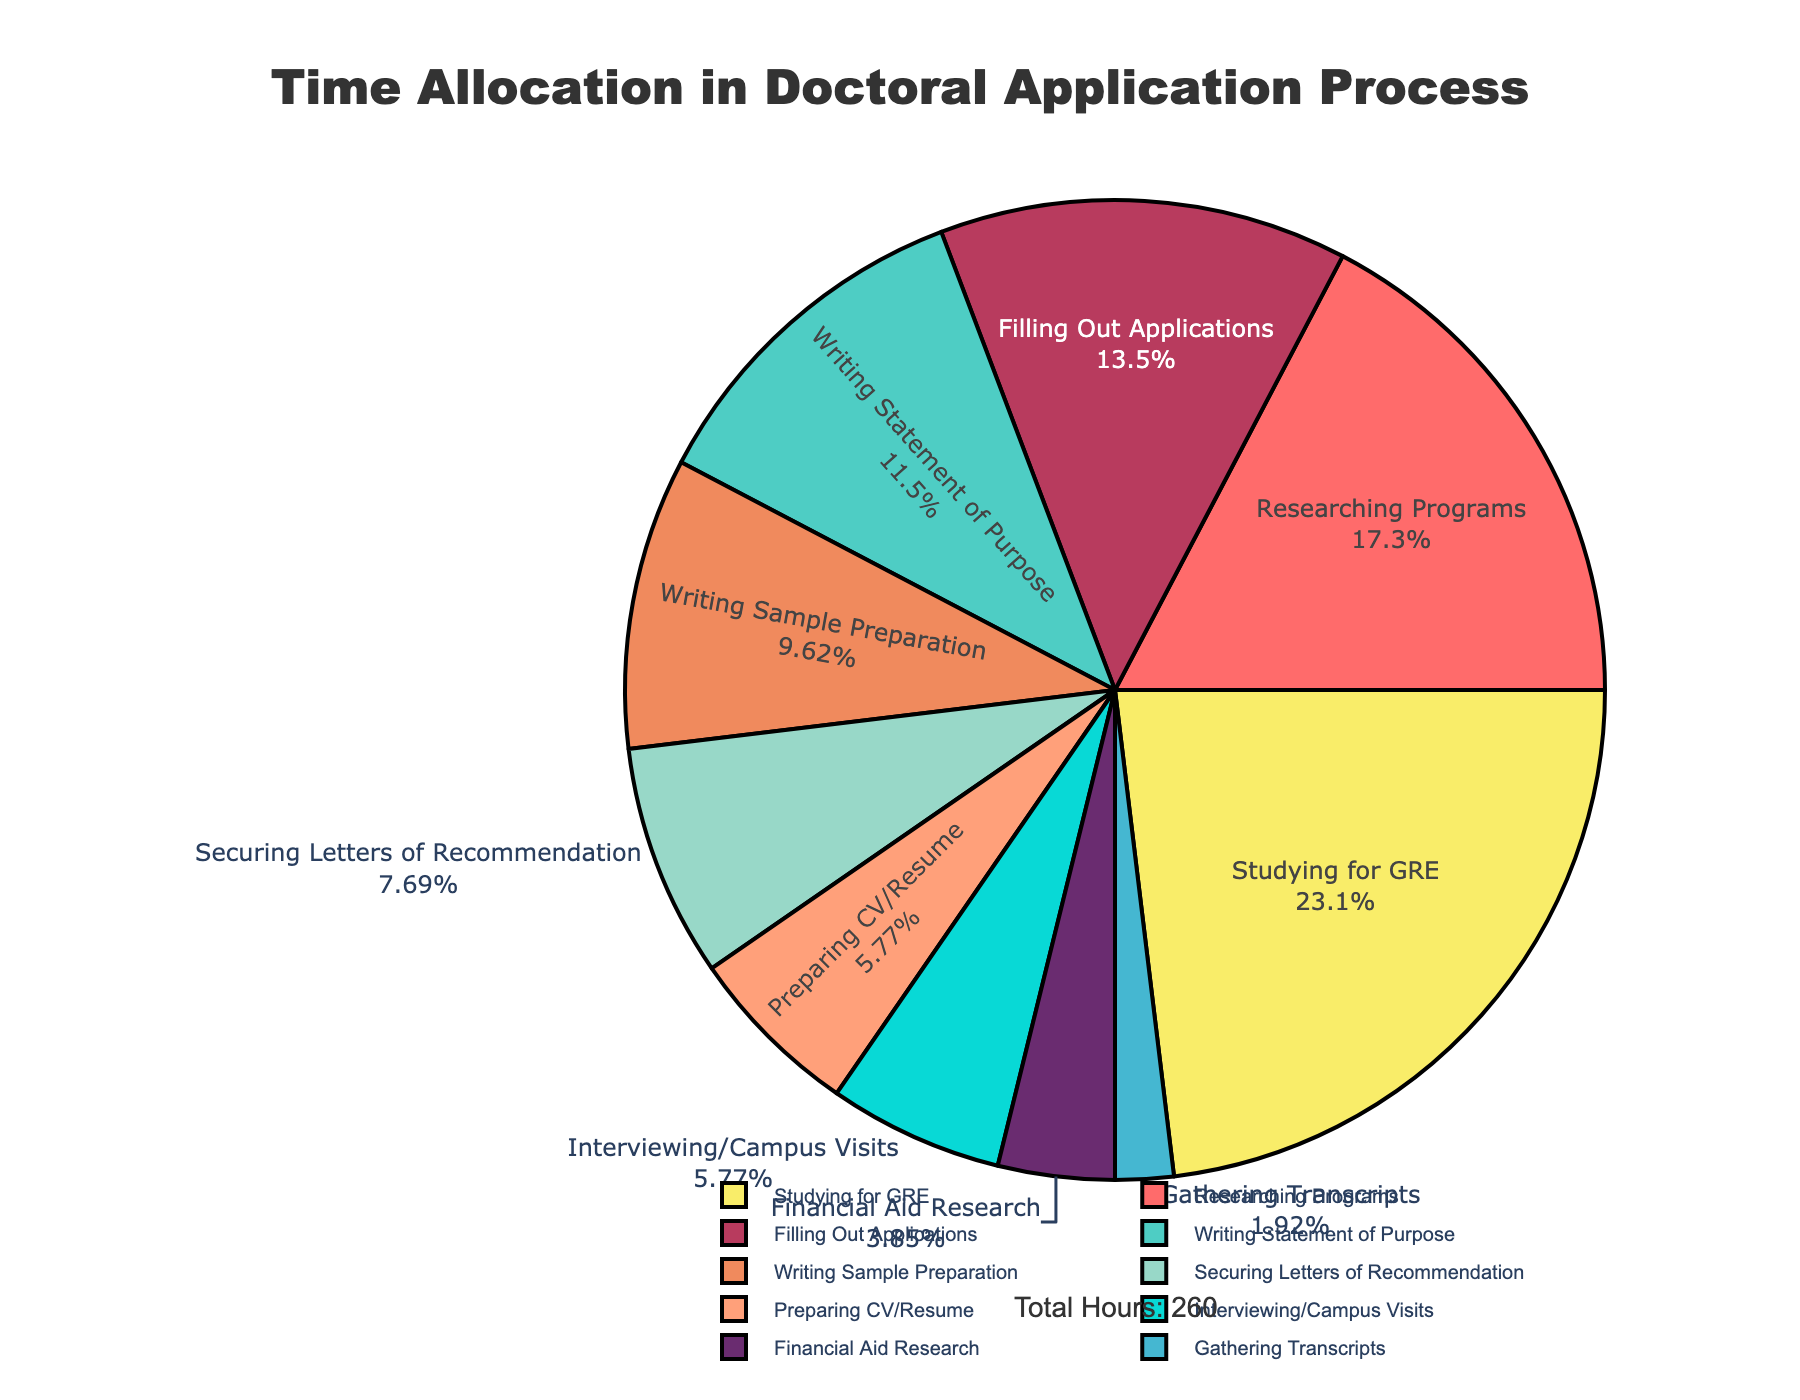Which activity consumes the most amount of time? By visually inspecting the pie chart, we can identify the largest segment, indicating the activity that takes up the most hours.
Answer: Studying for GRE How much combined time is spent on researching programs and filling out applications? Add the hours spent on "Researching Programs" (45) and "Filling Out Applications" (35) to get the combined time.
Answer: 80 hours Which activity takes less time: Preparing CV/Resume or Interviewing/Campus Visits? Compare the time spent on "Preparing CV/Resume" (15 hours) and "Interviewing/Campus Visits" (15 hours). They are identical.
Answer: Both take 15 hours Which activity is represented by the smallest segment of the pie chart? Find the smallest segment in the chart, which indicates the activity with the least hours.
Answer: Gathering Transcripts Which activities together make up more than 50% of the total time? Sum the hours of each activity starting from the largest, until the sum exceeds 50% of the total hours (260). "Studying for GRE" (60), "Researching Programs" (45), "Filling Out Applications" (35), and "Writing Statement of Purpose" (30) together exceed 50%.
Answer: Studying for GRE, Researching Programs, Filling Out Applications, Writing Statement of Purpose What percentage of time is spent on writing-related tasks? Sum the hours for "Writing Statement of Purpose" (30) and "Writing Sample Preparation" (25). Divide by the total hours (260) and multiply by 100 to find the percentage. (30 + 25) / 260 * 100 = 21.15%
Answer: 21.15% Which activity takes more time: preparing CV/Resume or gathering transcripts? Compare "Preparing CV/Resume" (15 hours) to "Gathering Transcripts" (5 hours) to see which is larger.
Answer: Preparing CV/Resume How many activities take more than 20 hours each? Count the sectors labeled with hours greater than 20. These are "Studying for GRE" (60), "Researching Programs" (45), "Filling Out Applications" (35), "Writing Statement of Purpose" (30), and "Writing Sample Preparation" (25), totaling 5 activities.
Answer: 5 activities What is the difference in hours between securing letters of recommendation and financial aid research? Subtract the hours for "Financial Aid Research" (10) from "Securing Letters of Recommendation" (20). 20 - 10 = 10
Answer: 10 hours 